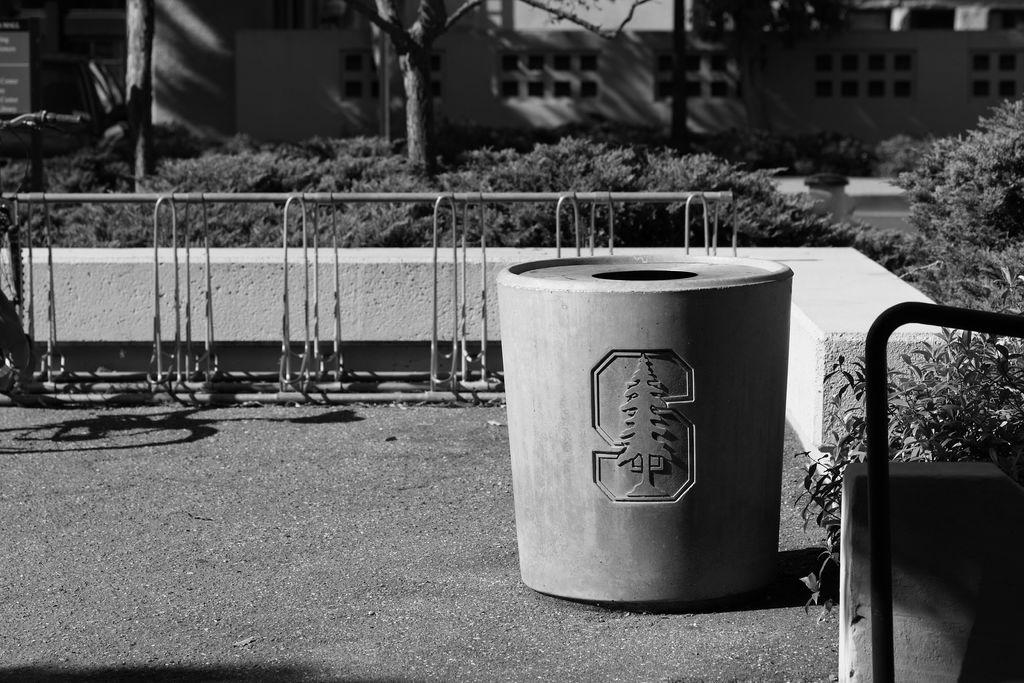What is the color scheme of the image? The image is black and white. What is placed on the ground in the image? There is a container placed on the ground. What type of structure can be seen in the image? There is a fence in the image. What type of natural elements are present in the image? Plants and the bark of trees are visible in the image. What type of building is present in the image? There is a building with windows in the image. What type of chair is visible in the image? There is no chair present in the image. Can you tell me the profession of the lawyer in the image? There is no lawyer present in the image. 